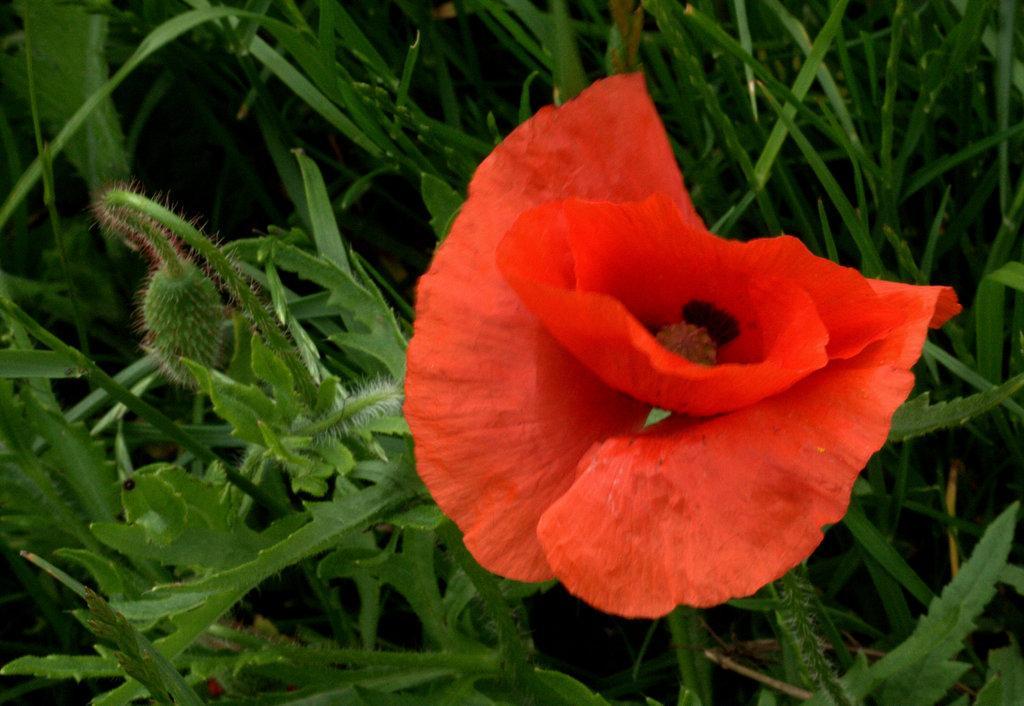Please provide a concise description of this image. In this image there is a flower, behind the flower there are plants. 